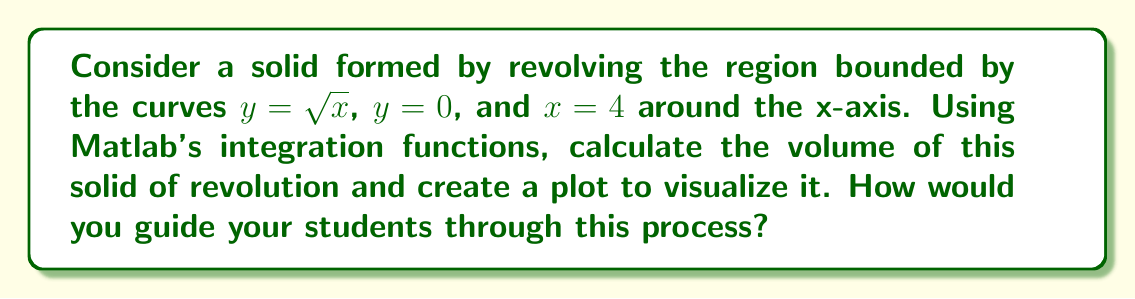Can you solve this math problem? To solve this problem and guide students through the process, we can follow these steps:

1. Identify the function and limits:
   The function is $f(x) = \sqrt{x}$, and the limits are from $x = 0$ to $x = 4$.

2. Set up the volume integral:
   The volume of a solid of revolution around the x-axis is given by:
   $$V = \pi \int_a^b [f(x)]^2 dx$$
   In this case, $V = \pi \int_0^4 (\sqrt{x})^2 dx = \pi \int_0^4 x dx$

3. Use Matlab's integration function:
   In Matlab, we can use the `integral` function to compute this:
   ```matlab
   f = @(x) pi * x;
   V = integral(f, 0, 4);
   ```

4. Plot the solid of revolution:
   To visualize the solid, we can use parametric equations:
   ```matlab
   [X, T] = meshgrid(linspace(0, 4, 50), linspace(0, 2*pi, 50));
   Y = sqrt(X) .* cos(T);
   Z = sqrt(X) .* sin(T);
   surf(X, Y, Z);
   ```

5. Explain the result:
   The volume calculated should be $\frac{16\pi}{3}$ cubic units. This can be verified analytically:
   $$V = \pi \int_0^4 x dx = \pi \left[\frac{x^2}{2}\right]_0^4 = \pi \left(8 - 0\right) = 8\pi = \frac{16\pi}{3}$$

6. Discuss the importance of visualization:
   The plot helps students understand the shape of the solid and how it relates to the original function. It also demonstrates the power of Matlab in visualizing mathematical concepts.

7. Extend the learning:
   Encourage students to experiment with different functions and limits to see how they affect the volume and shape of the solid.
Answer: The volume of the solid of revolution is $\frac{16\pi}{3}$ cubic units. The Matlab code to calculate and visualize this result is:

```matlab
f = @(x) pi * x;
V = integral(f, 0, 4);

[X, T] = meshgrid(linspace(0, 4, 50), linspace(0, 2*pi, 50));
Y = sqrt(X) .* cos(T);
Z = sqrt(X) .* sin(T);
surf(X, Y, Z);
title(['Volume = ' num2str(V) ' cubic units']);
``` 